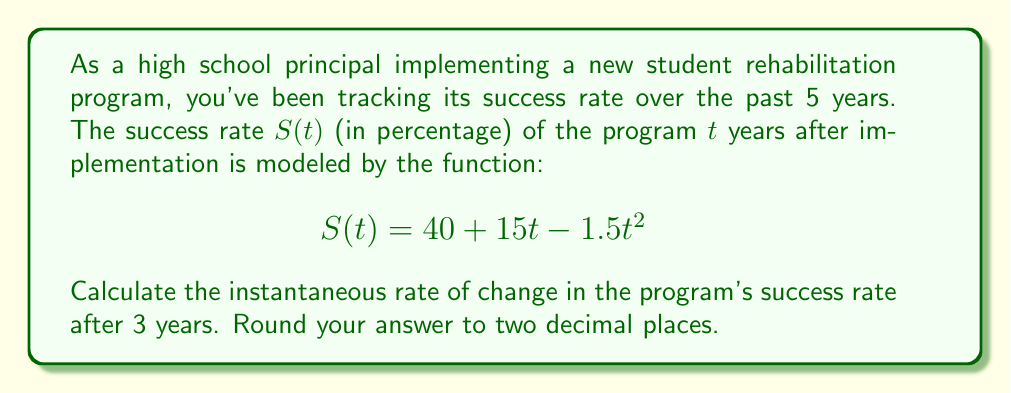Give your solution to this math problem. To find the instantaneous rate of change in the program's success rate after 3 years, we need to calculate the derivative of $S(t)$ and evaluate it at $t=3$.

Step 1: Find the derivative of $S(t)$
$$S(t) = 40 + 15t - 1.5t^2$$
$$S'(t) = 15 - 3t$$

Step 2: Evaluate $S'(t)$ at $t=3$
$$S'(3) = 15 - 3(3)$$
$$S'(3) = 15 - 9$$
$$S'(3) = 6$$

Step 3: Interpret the result
The instantaneous rate of change at $t=3$ is 6 percentage points per year. However, since it's positive, the success rate is still increasing, albeit at a slower rate than initially.

Step 4: Round to two decimal places
The result is already a whole number, so no rounding is necessary.
Answer: 6 percentage points per year 